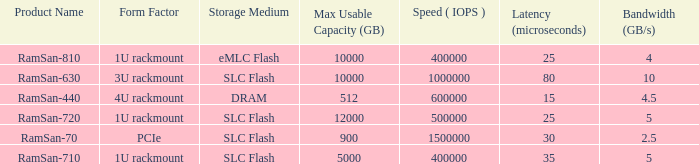What is the ramsan-810 transfer delay? 1.0. 